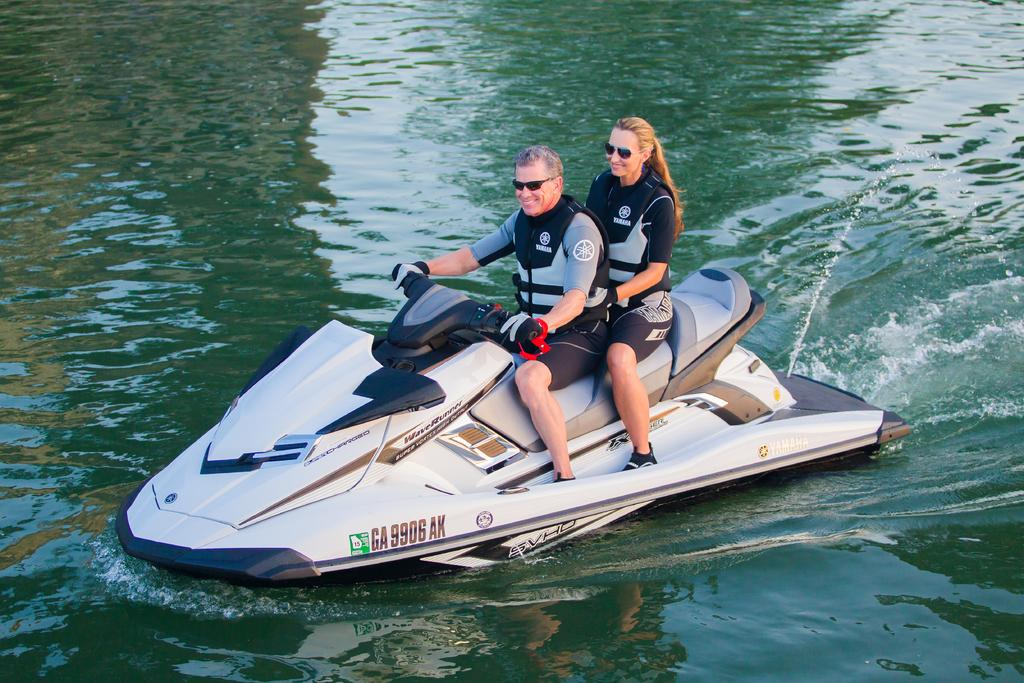How many people are in the image? There are two persons in the image. What are the persons doing in the image? The persons are smiling. Where are the persons sitting in the image? The persons are sitting on a motor boat. What is the motor boat's location in the image? The motor boat is on the water. What type of collar can be seen on the person sitting in the front of the motor boat? There is no collar visible on any person in the image, as they are not wearing any clothing that would have a collar. 